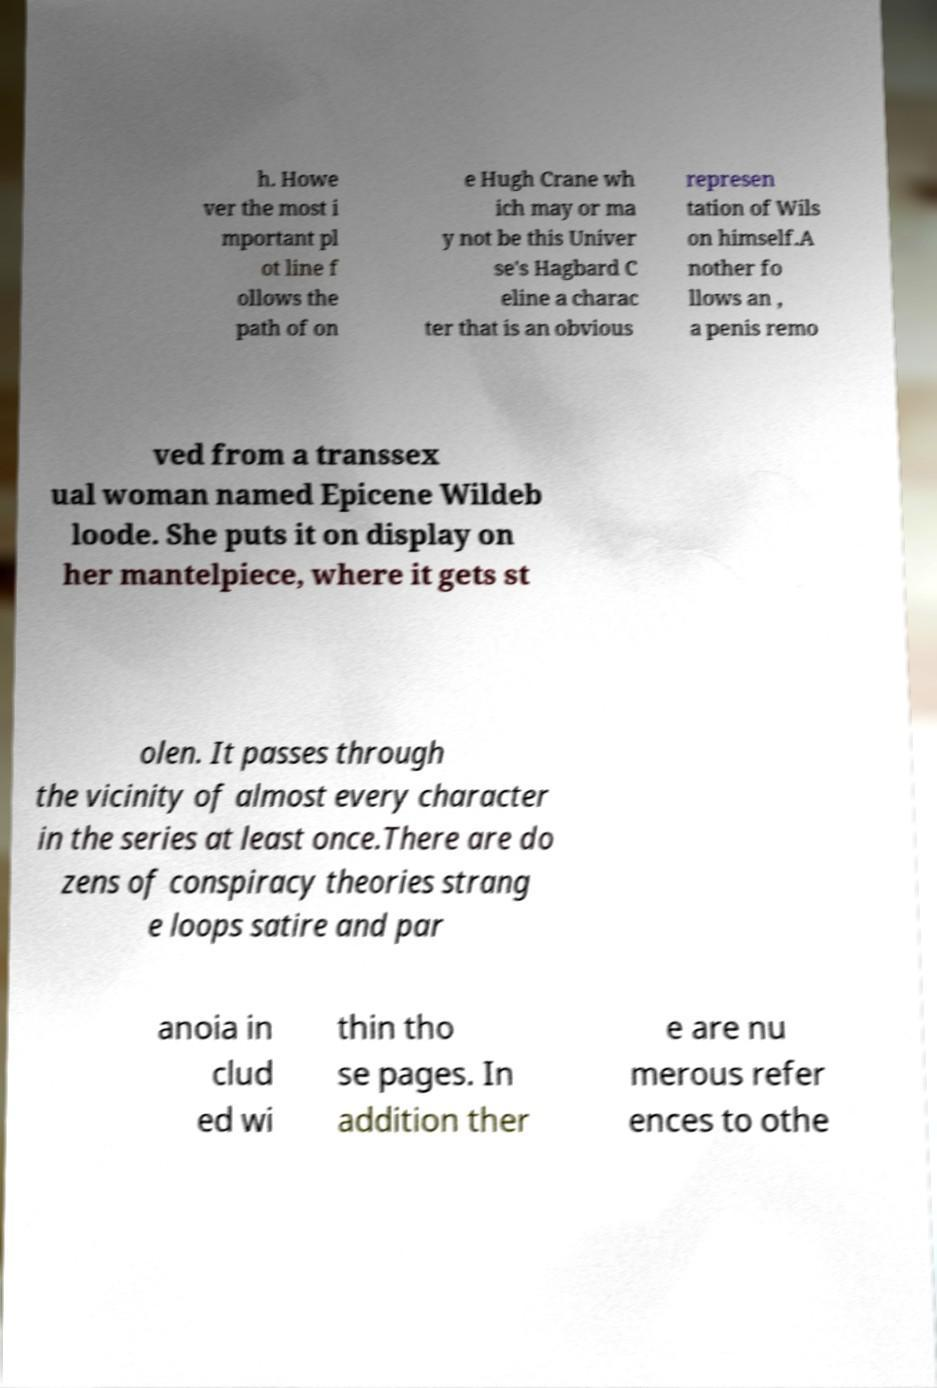There's text embedded in this image that I need extracted. Can you transcribe it verbatim? h. Howe ver the most i mportant pl ot line f ollows the path of on e Hugh Crane wh ich may or ma y not be this Univer se's Hagbard C eline a charac ter that is an obvious represen tation of Wils on himself.A nother fo llows an , a penis remo ved from a transsex ual woman named Epicene Wildeb loode. She puts it on display on her mantelpiece, where it gets st olen. It passes through the vicinity of almost every character in the series at least once.There are do zens of conspiracy theories strang e loops satire and par anoia in clud ed wi thin tho se pages. In addition ther e are nu merous refer ences to othe 